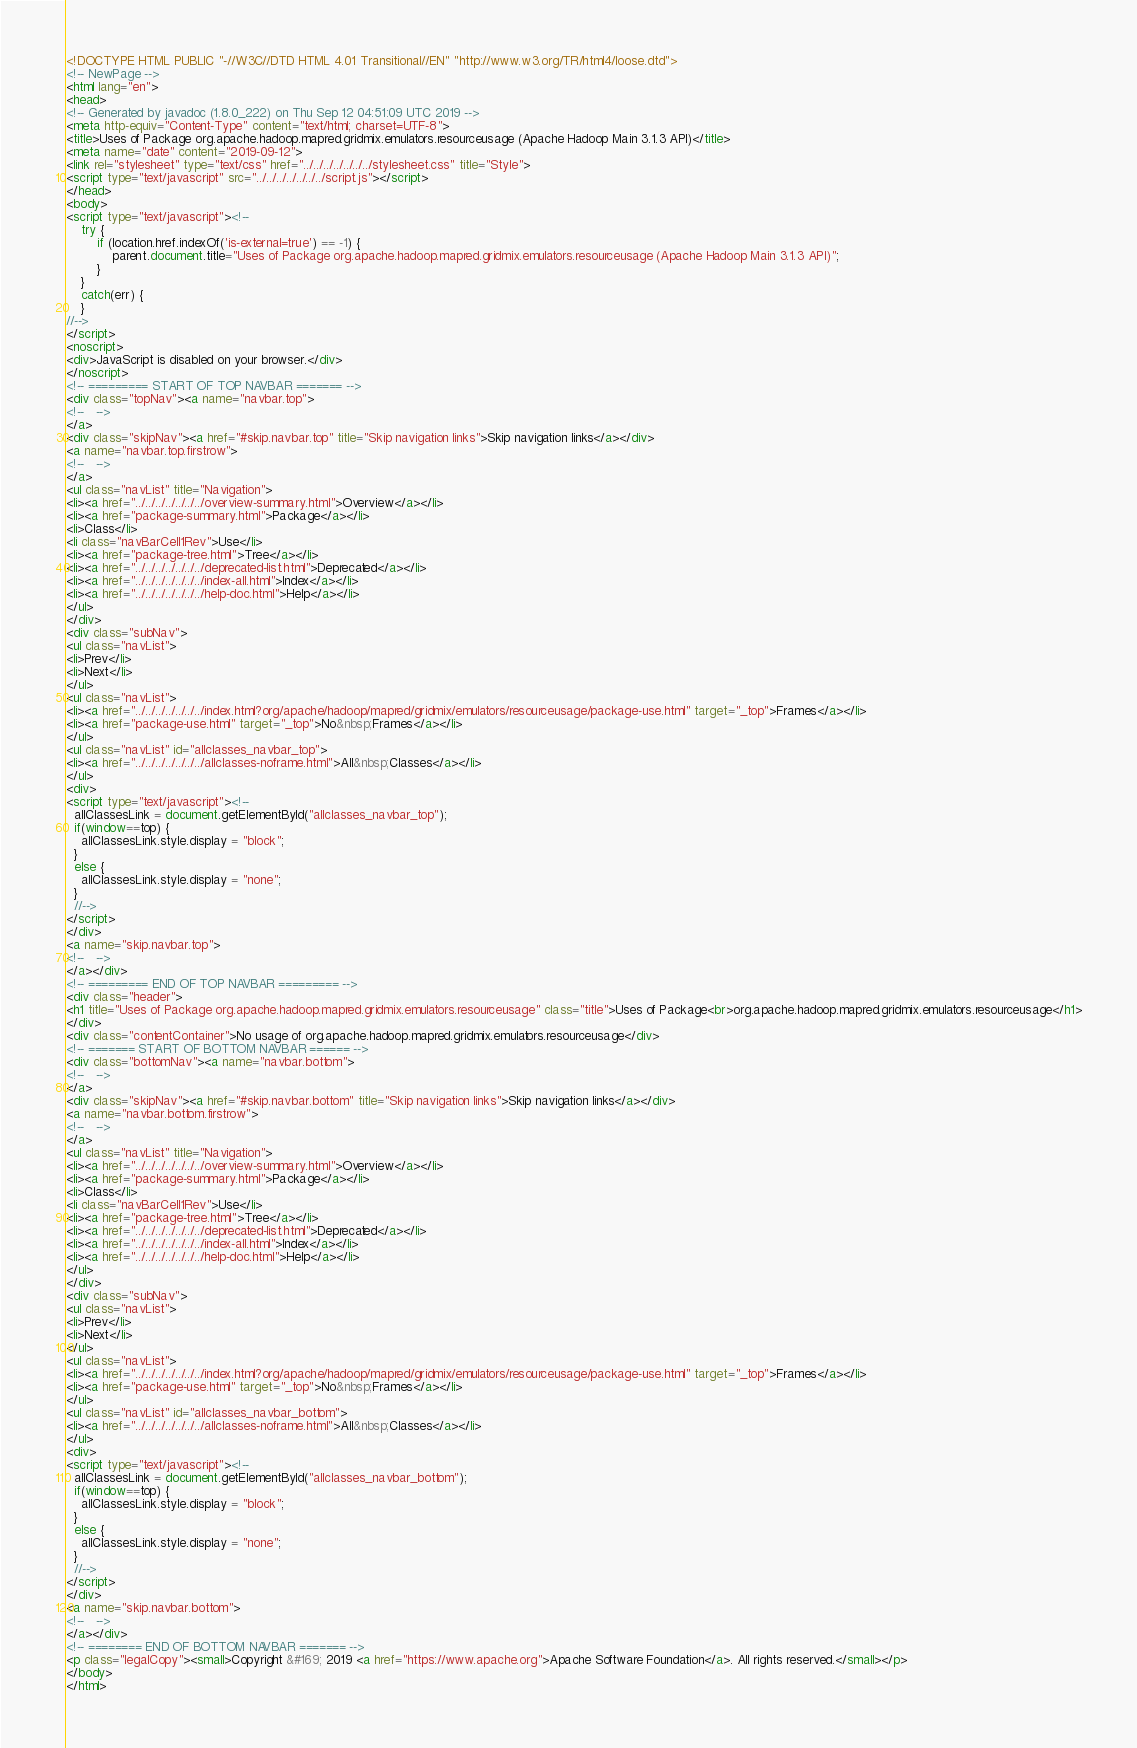<code> <loc_0><loc_0><loc_500><loc_500><_HTML_><!DOCTYPE HTML PUBLIC "-//W3C//DTD HTML 4.01 Transitional//EN" "http://www.w3.org/TR/html4/loose.dtd">
<!-- NewPage -->
<html lang="en">
<head>
<!-- Generated by javadoc (1.8.0_222) on Thu Sep 12 04:51:09 UTC 2019 -->
<meta http-equiv="Content-Type" content="text/html; charset=UTF-8">
<title>Uses of Package org.apache.hadoop.mapred.gridmix.emulators.resourceusage (Apache Hadoop Main 3.1.3 API)</title>
<meta name="date" content="2019-09-12">
<link rel="stylesheet" type="text/css" href="../../../../../../../stylesheet.css" title="Style">
<script type="text/javascript" src="../../../../../../../script.js"></script>
</head>
<body>
<script type="text/javascript"><!--
    try {
        if (location.href.indexOf('is-external=true') == -1) {
            parent.document.title="Uses of Package org.apache.hadoop.mapred.gridmix.emulators.resourceusage (Apache Hadoop Main 3.1.3 API)";
        }
    }
    catch(err) {
    }
//-->
</script>
<noscript>
<div>JavaScript is disabled on your browser.</div>
</noscript>
<!-- ========= START OF TOP NAVBAR ======= -->
<div class="topNav"><a name="navbar.top">
<!--   -->
</a>
<div class="skipNav"><a href="#skip.navbar.top" title="Skip navigation links">Skip navigation links</a></div>
<a name="navbar.top.firstrow">
<!--   -->
</a>
<ul class="navList" title="Navigation">
<li><a href="../../../../../../../overview-summary.html">Overview</a></li>
<li><a href="package-summary.html">Package</a></li>
<li>Class</li>
<li class="navBarCell1Rev">Use</li>
<li><a href="package-tree.html">Tree</a></li>
<li><a href="../../../../../../../deprecated-list.html">Deprecated</a></li>
<li><a href="../../../../../../../index-all.html">Index</a></li>
<li><a href="../../../../../../../help-doc.html">Help</a></li>
</ul>
</div>
<div class="subNav">
<ul class="navList">
<li>Prev</li>
<li>Next</li>
</ul>
<ul class="navList">
<li><a href="../../../../../../../index.html?org/apache/hadoop/mapred/gridmix/emulators/resourceusage/package-use.html" target="_top">Frames</a></li>
<li><a href="package-use.html" target="_top">No&nbsp;Frames</a></li>
</ul>
<ul class="navList" id="allclasses_navbar_top">
<li><a href="../../../../../../../allclasses-noframe.html">All&nbsp;Classes</a></li>
</ul>
<div>
<script type="text/javascript"><!--
  allClassesLink = document.getElementById("allclasses_navbar_top");
  if(window==top) {
    allClassesLink.style.display = "block";
  }
  else {
    allClassesLink.style.display = "none";
  }
  //-->
</script>
</div>
<a name="skip.navbar.top">
<!--   -->
</a></div>
<!-- ========= END OF TOP NAVBAR ========= -->
<div class="header">
<h1 title="Uses of Package org.apache.hadoop.mapred.gridmix.emulators.resourceusage" class="title">Uses of Package<br>org.apache.hadoop.mapred.gridmix.emulators.resourceusage</h1>
</div>
<div class="contentContainer">No usage of org.apache.hadoop.mapred.gridmix.emulators.resourceusage</div>
<!-- ======= START OF BOTTOM NAVBAR ====== -->
<div class="bottomNav"><a name="navbar.bottom">
<!--   -->
</a>
<div class="skipNav"><a href="#skip.navbar.bottom" title="Skip navigation links">Skip navigation links</a></div>
<a name="navbar.bottom.firstrow">
<!--   -->
</a>
<ul class="navList" title="Navigation">
<li><a href="../../../../../../../overview-summary.html">Overview</a></li>
<li><a href="package-summary.html">Package</a></li>
<li>Class</li>
<li class="navBarCell1Rev">Use</li>
<li><a href="package-tree.html">Tree</a></li>
<li><a href="../../../../../../../deprecated-list.html">Deprecated</a></li>
<li><a href="../../../../../../../index-all.html">Index</a></li>
<li><a href="../../../../../../../help-doc.html">Help</a></li>
</ul>
</div>
<div class="subNav">
<ul class="navList">
<li>Prev</li>
<li>Next</li>
</ul>
<ul class="navList">
<li><a href="../../../../../../../index.html?org/apache/hadoop/mapred/gridmix/emulators/resourceusage/package-use.html" target="_top">Frames</a></li>
<li><a href="package-use.html" target="_top">No&nbsp;Frames</a></li>
</ul>
<ul class="navList" id="allclasses_navbar_bottom">
<li><a href="../../../../../../../allclasses-noframe.html">All&nbsp;Classes</a></li>
</ul>
<div>
<script type="text/javascript"><!--
  allClassesLink = document.getElementById("allclasses_navbar_bottom");
  if(window==top) {
    allClassesLink.style.display = "block";
  }
  else {
    allClassesLink.style.display = "none";
  }
  //-->
</script>
</div>
<a name="skip.navbar.bottom">
<!--   -->
</a></div>
<!-- ======== END OF BOTTOM NAVBAR ======= -->
<p class="legalCopy"><small>Copyright &#169; 2019 <a href="https://www.apache.org">Apache Software Foundation</a>. All rights reserved.</small></p>
</body>
</html>
</code> 